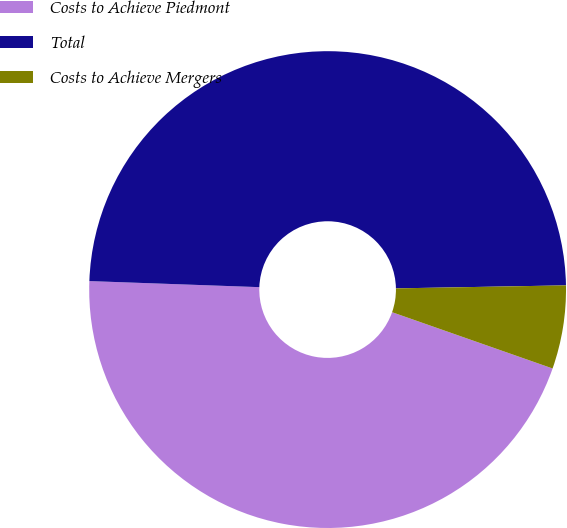Convert chart. <chart><loc_0><loc_0><loc_500><loc_500><pie_chart><fcel>Costs to Achieve Piedmont<fcel>Total<fcel>Costs to Achieve Mergers<nl><fcel>45.2%<fcel>49.15%<fcel>5.65%<nl></chart> 